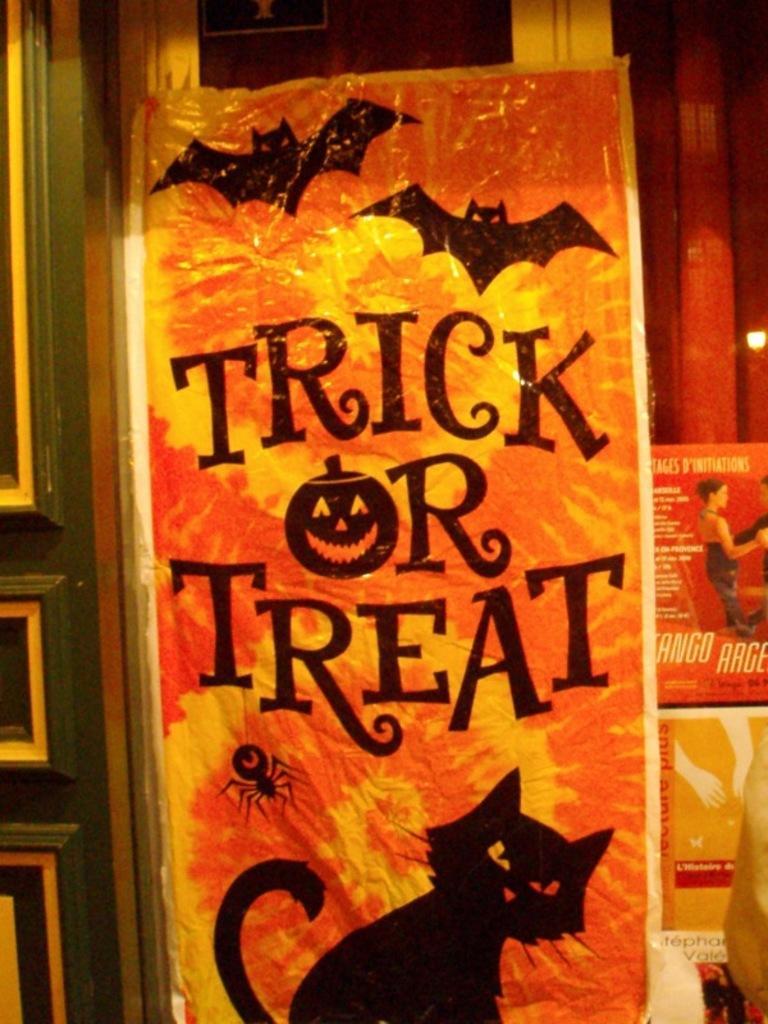Describe this image in one or two sentences. In this image I see orange color board on which there is something written and I see the depiction of bats, spider and a cat on it and in the background I see the red color thing on which there is a depiction of a woman and I see something is written on it too and I see a yellow color thing on which there are depiction of hands and I see something written over here too. 